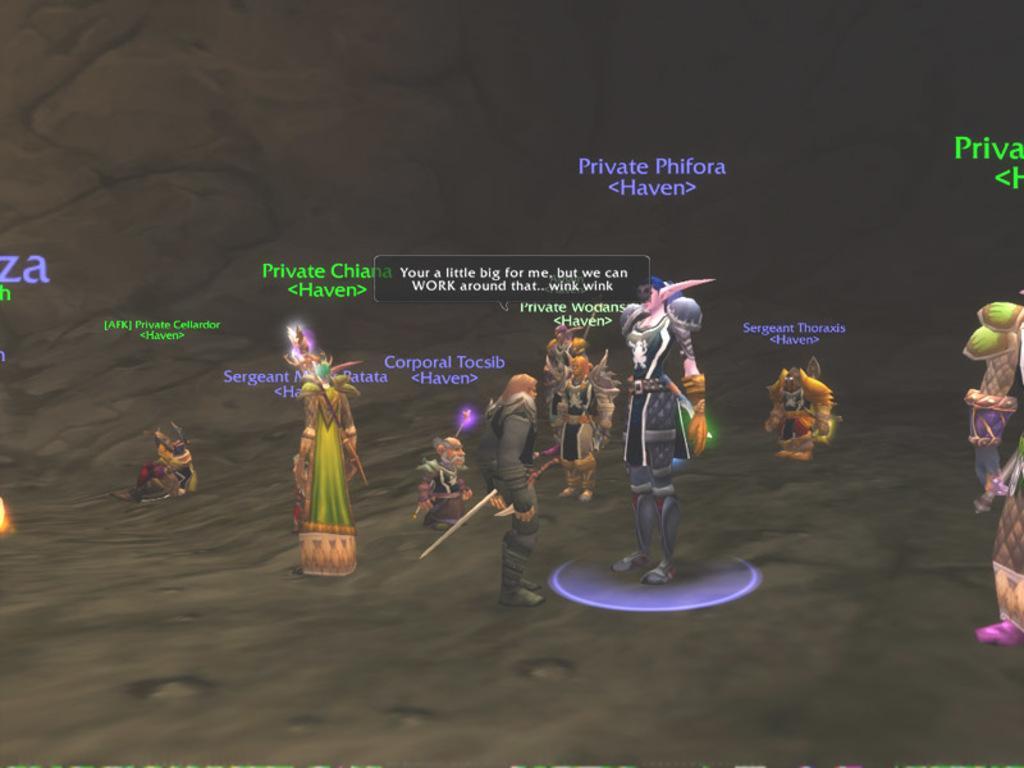Can you describe this image briefly? In this image I can see the animated picture and I can see few persons standing and holding few objects and I can see something written on the image. 